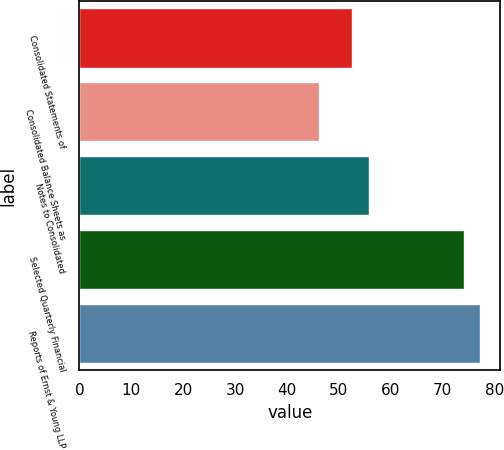Convert chart to OTSL. <chart><loc_0><loc_0><loc_500><loc_500><bar_chart><fcel>Consolidated Statements of<fcel>Consolidated Balance Sheets as<fcel>Notes to Consolidated<fcel>Selected Quarterly Financial<fcel>Reports of Ernst & Young LLP<nl><fcel>52.6<fcel>46.2<fcel>55.8<fcel>74<fcel>77.2<nl></chart> 